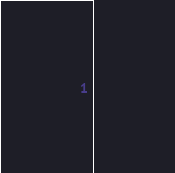Convert code to text. <code><loc_0><loc_0><loc_500><loc_500><_SQL_>


</code> 